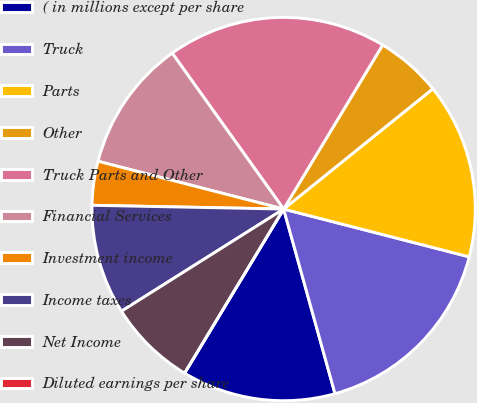Convert chart. <chart><loc_0><loc_0><loc_500><loc_500><pie_chart><fcel>( in millions except per share<fcel>Truck<fcel>Parts<fcel>Other<fcel>Truck Parts and Other<fcel>Financial Services<fcel>Investment income<fcel>Income taxes<fcel>Net Income<fcel>Diluted earnings per share<nl><fcel>12.96%<fcel>16.67%<fcel>14.81%<fcel>5.56%<fcel>18.52%<fcel>11.11%<fcel>3.7%<fcel>9.26%<fcel>7.41%<fcel>0.0%<nl></chart> 